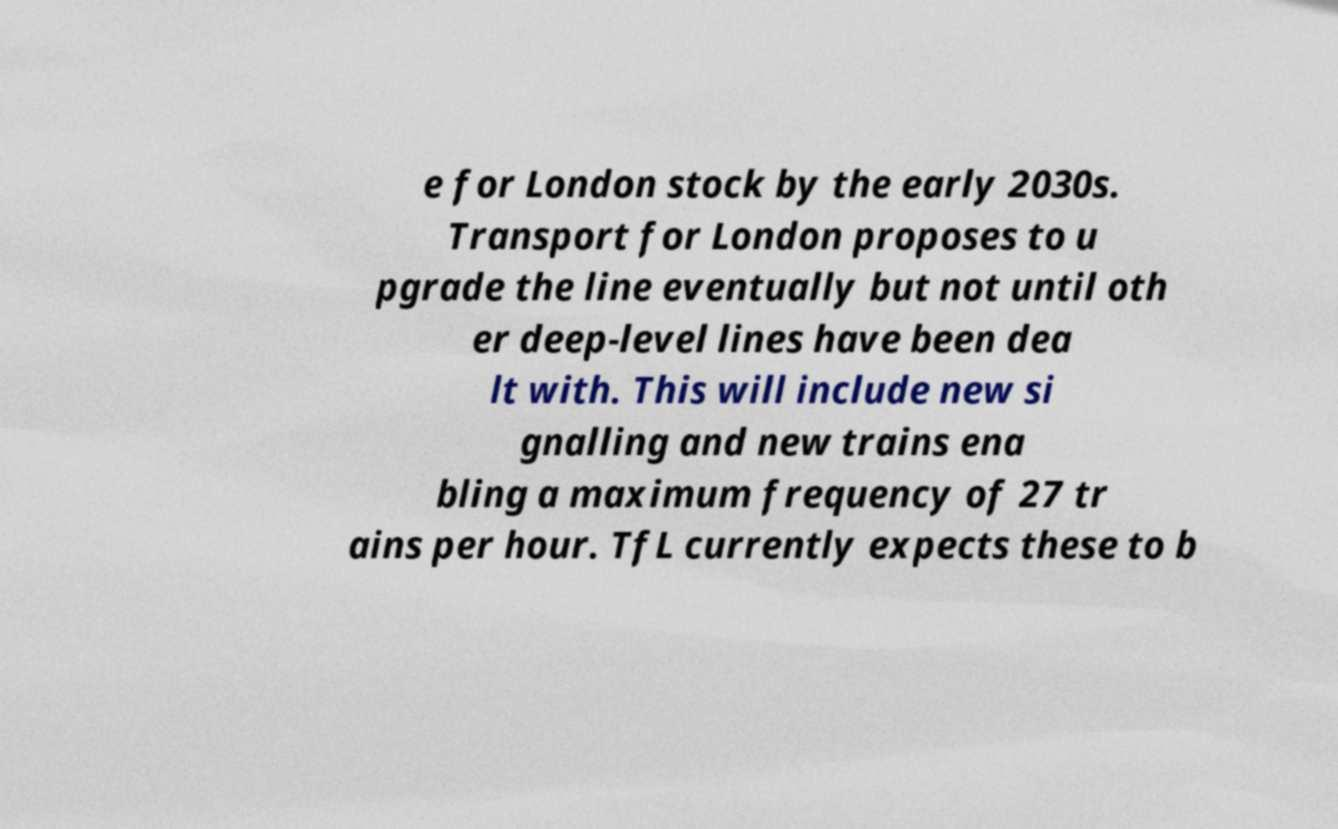I need the written content from this picture converted into text. Can you do that? e for London stock by the early 2030s. Transport for London proposes to u pgrade the line eventually but not until oth er deep-level lines have been dea lt with. This will include new si gnalling and new trains ena bling a maximum frequency of 27 tr ains per hour. TfL currently expects these to b 